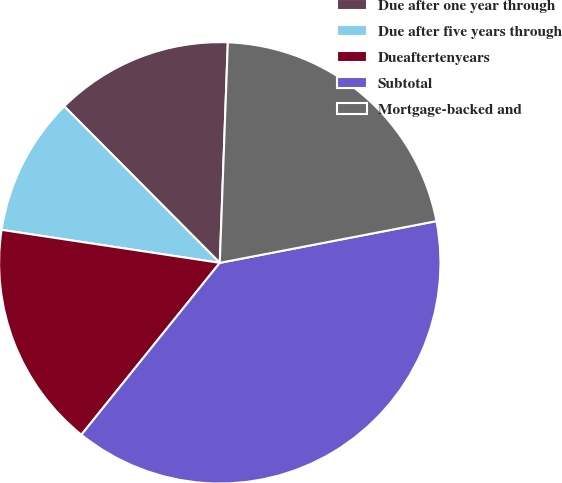Convert chart. <chart><loc_0><loc_0><loc_500><loc_500><pie_chart><fcel>Due after one year through<fcel>Due after five years through<fcel>Dueaftertenyears<fcel>Subtotal<fcel>Mortgage-backed and<nl><fcel>13.03%<fcel>10.16%<fcel>16.6%<fcel>38.81%<fcel>21.39%<nl></chart> 